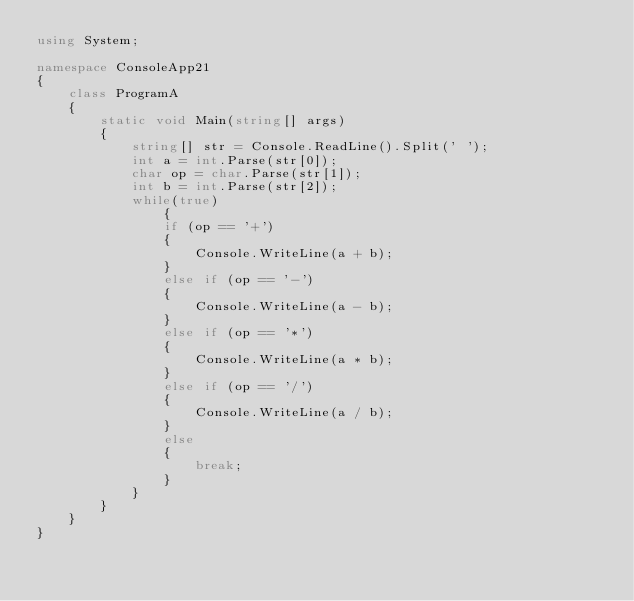<code> <loc_0><loc_0><loc_500><loc_500><_C#_>using System;

namespace ConsoleApp21
{
    class ProgramA
    {
        static void Main(string[] args)
        {
            string[] str = Console.ReadLine().Split(' ');
            int a = int.Parse(str[0]);
            char op = char.Parse(str[1]);
            int b = int.Parse(str[2]);
            while(true)
                {
                if (op == '+')
                {
                    Console.WriteLine(a + b);
                }
                else if (op == '-')
                {
                    Console.WriteLine(a - b);
                }
                else if (op == '*')
                {
                    Console.WriteLine(a * b);
                }
                else if (op == '/')
                {
                    Console.WriteLine(a / b);
                }
                else
                {
                    break;
                }
            }
        }
    }
}</code> 